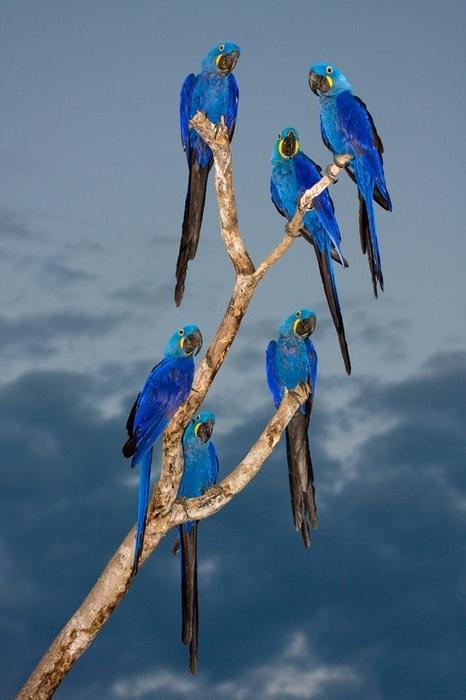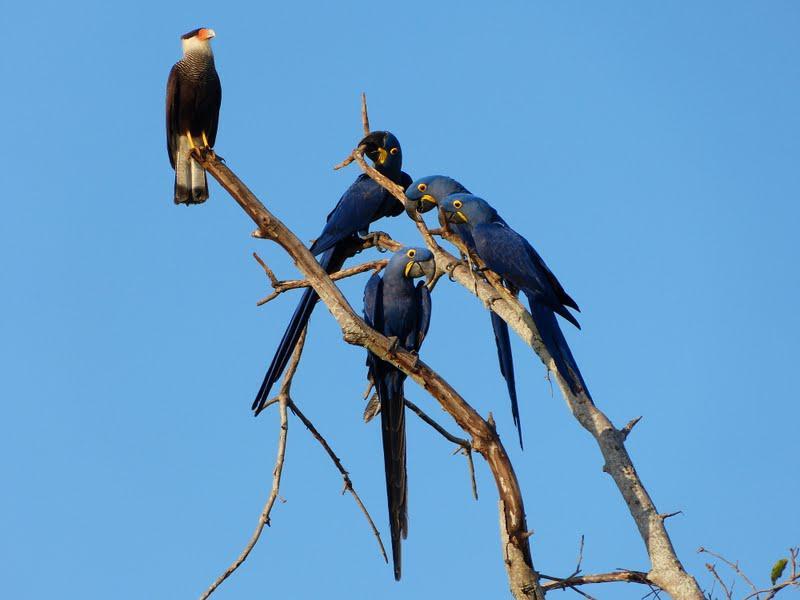The first image is the image on the left, the second image is the image on the right. For the images displayed, is the sentence "There is exactly one bird in the image on the right." factually correct? Answer yes or no. No. 